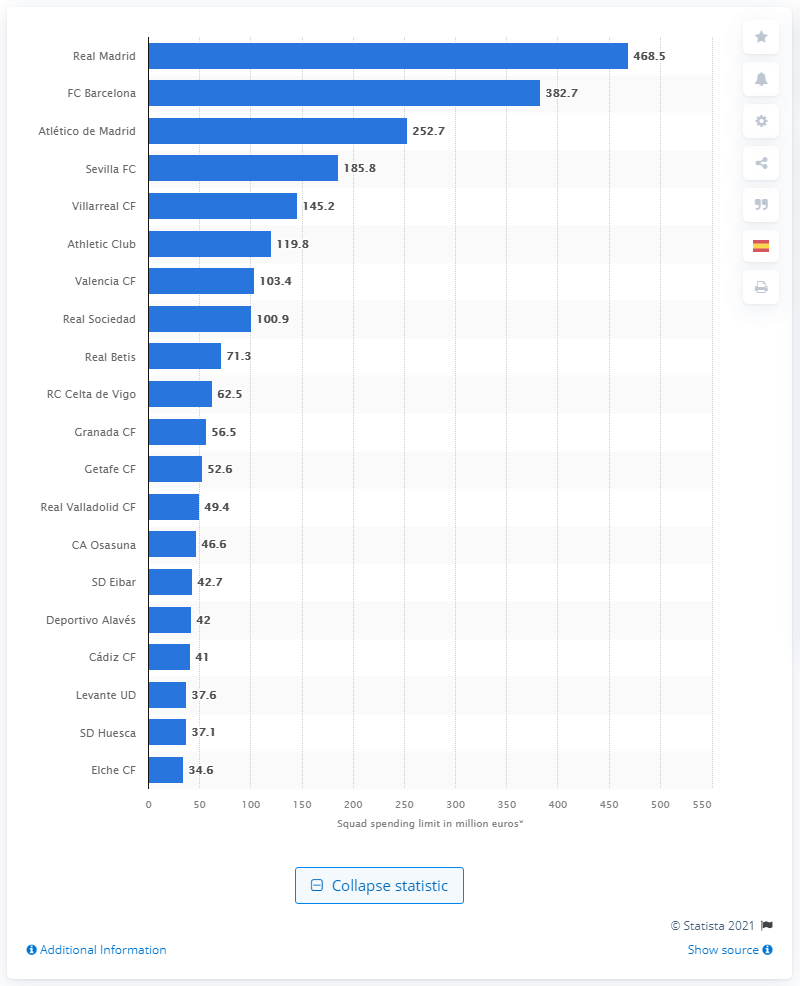List a handful of essential elements in this visual. The budget limit for Real Madrid for the 2020/2021 season was 468.5 million euros. The budget for FC Barcelona was 382.7 million dollars. 